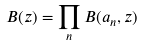Convert formula to latex. <formula><loc_0><loc_0><loc_500><loc_500>B ( z ) = \prod _ { n } B ( a _ { n } , z )</formula> 